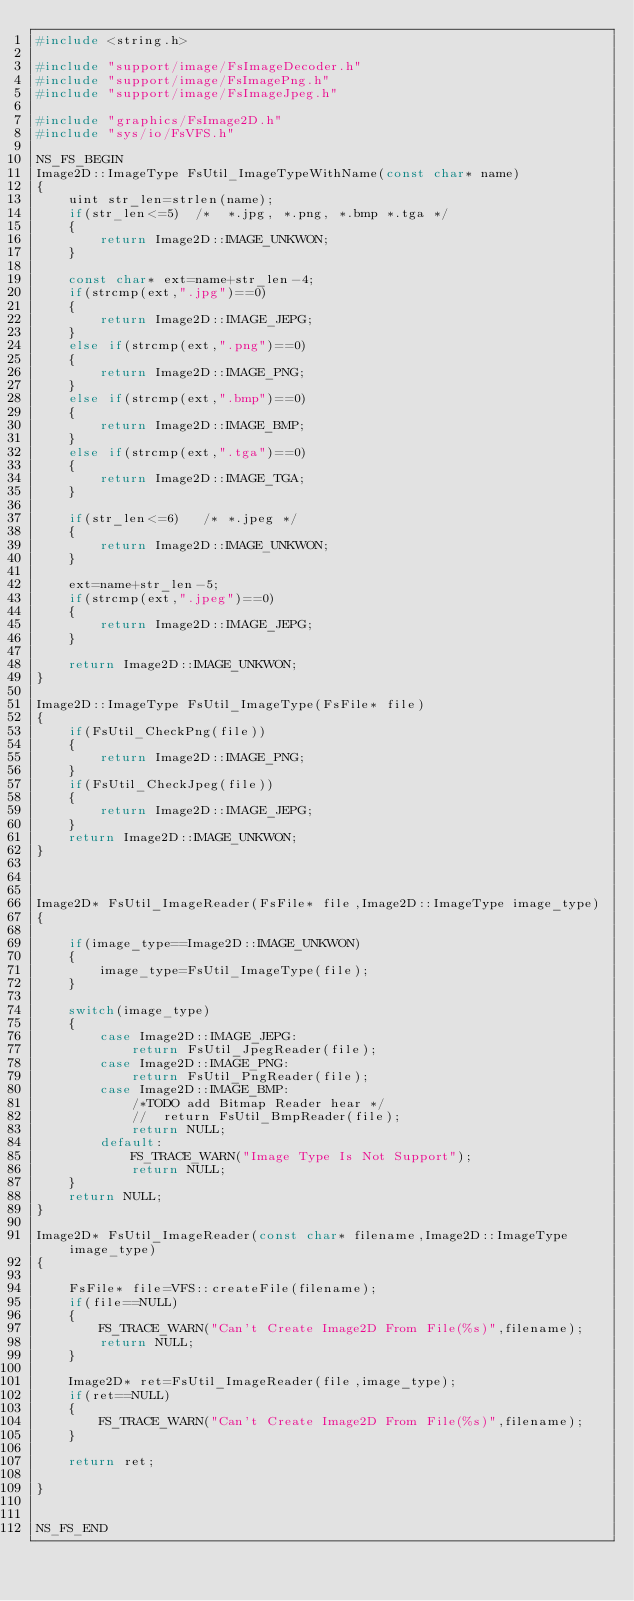Convert code to text. <code><loc_0><loc_0><loc_500><loc_500><_C++_>#include <string.h>

#include "support/image/FsImageDecoder.h"
#include "support/image/FsImagePng.h"
#include "support/image/FsImageJpeg.h"

#include "graphics/FsImage2D.h"
#include "sys/io/FsVFS.h"

NS_FS_BEGIN
Image2D::ImageType FsUtil_ImageTypeWithName(const char* name)
{
	uint str_len=strlen(name);
	if(str_len<=5)  /*  *.jpg, *.png, *.bmp *.tga */
	{
		return Image2D::IMAGE_UNKWON;
	}

	const char* ext=name+str_len-4;
	if(strcmp(ext,".jpg")==0)
	{
		return Image2D::IMAGE_JEPG;
	}
	else if(strcmp(ext,".png")==0)
	{
		return Image2D::IMAGE_PNG;
	}
	else if(strcmp(ext,".bmp")==0)
	{
		return Image2D::IMAGE_BMP;
	}
	else if(strcmp(ext,".tga")==0)
	{
		return Image2D::IMAGE_TGA;
	}

	if(str_len<=6)   /* *.jpeg */
	{
		return Image2D::IMAGE_UNKWON;
	}

	ext=name+str_len-5;
	if(strcmp(ext,".jpeg")==0)
	{
		return Image2D::IMAGE_JEPG;
	}

	return Image2D::IMAGE_UNKWON;
}

Image2D::ImageType FsUtil_ImageType(FsFile* file)
{
	if(FsUtil_CheckPng(file))
	{
		return Image2D::IMAGE_PNG;
	}
	if(FsUtil_CheckJpeg(file))
	{
		return Image2D::IMAGE_JEPG;
	}
	return Image2D::IMAGE_UNKWON;
}



Image2D* FsUtil_ImageReader(FsFile* file,Image2D::ImageType image_type)
{

	if(image_type==Image2D::IMAGE_UNKWON)
	{
		image_type=FsUtil_ImageType(file);
	}

	switch(image_type)
	{
		case Image2D::IMAGE_JEPG:
			return FsUtil_JpegReader(file);
		case Image2D::IMAGE_PNG:
			return FsUtil_PngReader(file);
		case Image2D::IMAGE_BMP:
			/*TODO add Bitmap Reader hear */
			//	return FsUtil_BmpReader(file);
			return NULL;
		default:
			FS_TRACE_WARN("Image Type Is Not Support");
			return NULL;
	}
	return NULL;
}

Image2D* FsUtil_ImageReader(const char* filename,Image2D::ImageType image_type)
{

	FsFile* file=VFS::createFile(filename);
	if(file==NULL)
	{
		FS_TRACE_WARN("Can't Create Image2D From File(%s)",filename);
		return NULL;
	}
	
	Image2D* ret=FsUtil_ImageReader(file,image_type);
	if(ret==NULL)
	{
		FS_TRACE_WARN("Can't Create Image2D From File(%s)",filename);
	}

	return ret;

}


NS_FS_END






</code> 